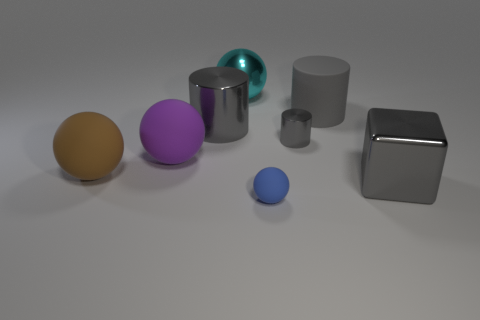What is the color of the small object that is in front of the purple rubber object?
Provide a succinct answer. Blue. Do the metallic cylinder that is on the right side of the tiny blue matte object and the big cube have the same color?
Ensure brevity in your answer.  Yes. There is a brown object that is the same shape as the cyan thing; what is its material?
Keep it short and to the point. Rubber. What number of purple objects are the same size as the blue matte object?
Make the answer very short. 0. What is the shape of the brown thing?
Keep it short and to the point. Sphere. What is the size of the matte object that is behind the small matte object and in front of the large purple rubber ball?
Your response must be concise. Large. What is the material of the large gray cylinder that is on the right side of the large metallic ball?
Keep it short and to the point. Rubber. There is a large metal cube; does it have the same color as the matte thing that is in front of the large brown matte object?
Your answer should be very brief. No. What number of things are either big matte objects on the right side of the tiny blue sphere or metal cylinders to the left of the small gray object?
Give a very brief answer. 2. What is the color of the big metal thing that is both in front of the cyan ball and left of the tiny rubber object?
Your answer should be very brief. Gray. 